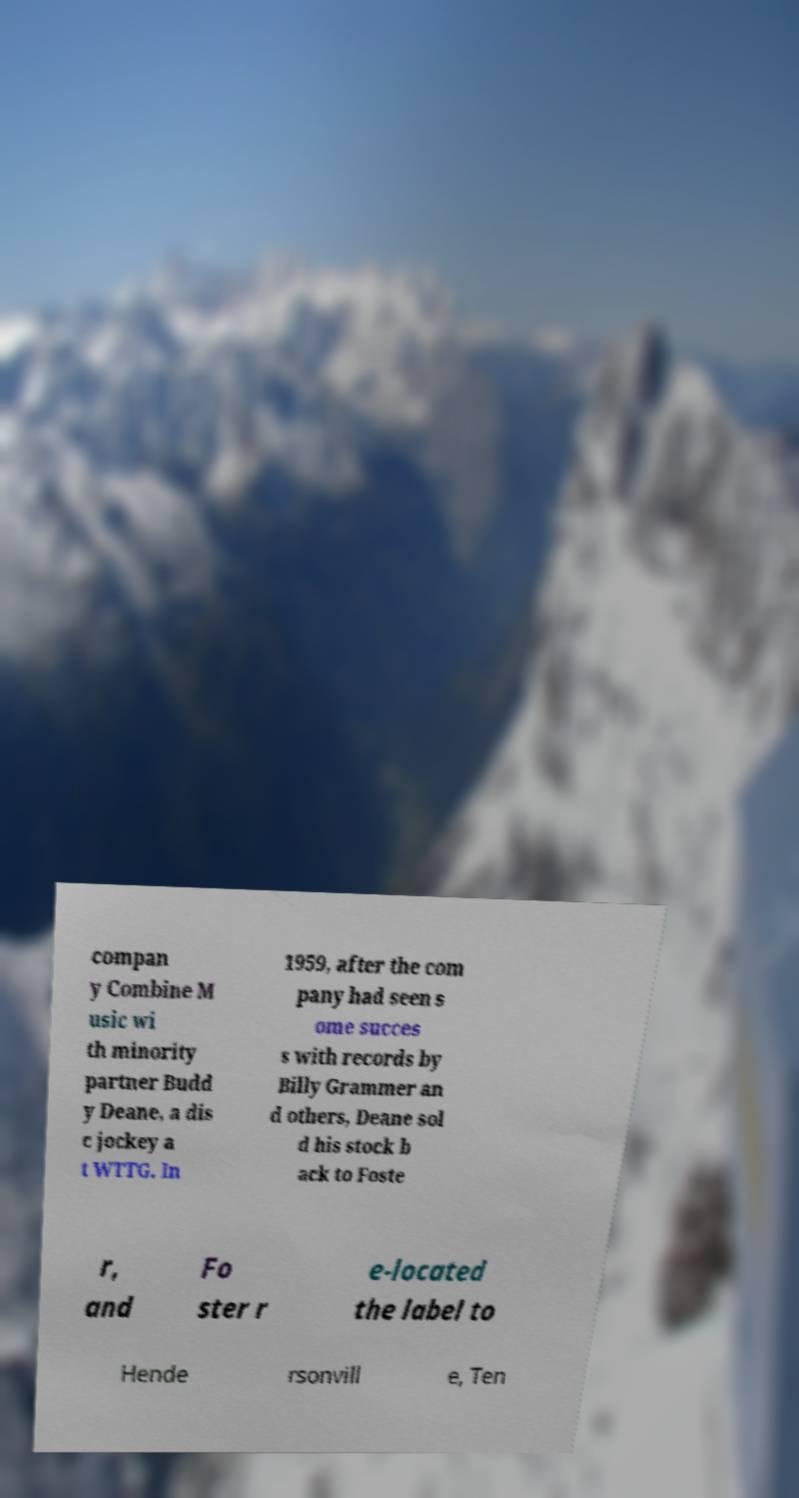Please identify and transcribe the text found in this image. compan y Combine M usic wi th minority partner Budd y Deane, a dis c jockey a t WTTG. In 1959, after the com pany had seen s ome succes s with records by Billy Grammer an d others, Deane sol d his stock b ack to Foste r, and Fo ster r e-located the label to Hende rsonvill e, Ten 